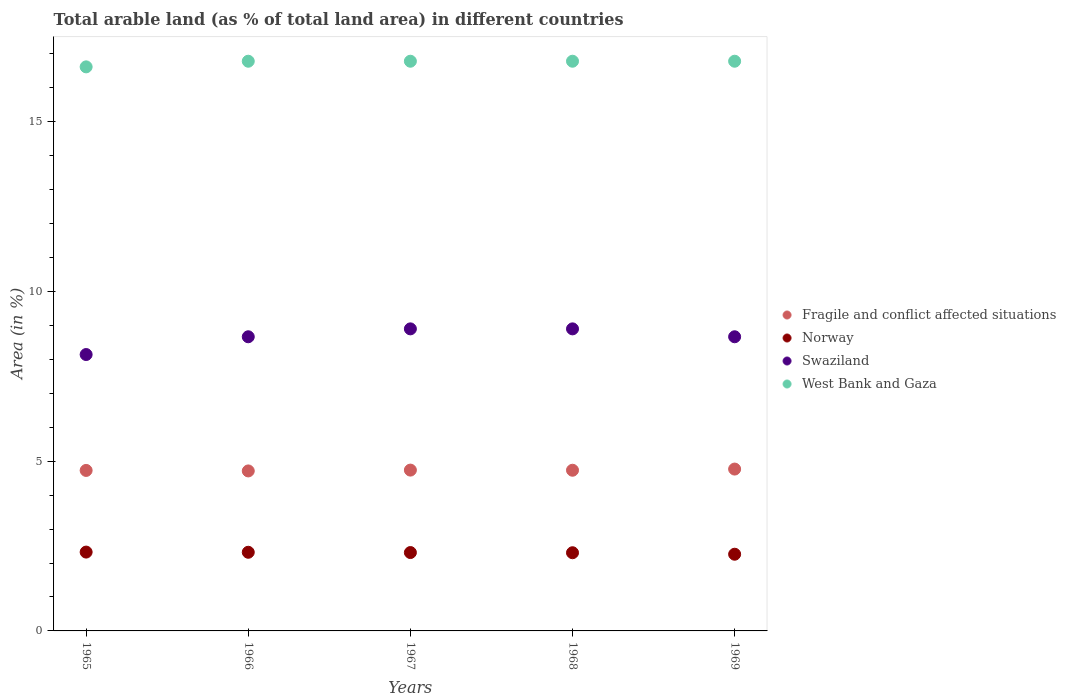What is the percentage of arable land in Fragile and conflict affected situations in 1968?
Your answer should be very brief. 4.73. Across all years, what is the maximum percentage of arable land in West Bank and Gaza?
Offer a very short reply. 16.78. Across all years, what is the minimum percentage of arable land in Swaziland?
Offer a very short reply. 8.14. In which year was the percentage of arable land in Swaziland maximum?
Your response must be concise. 1967. In which year was the percentage of arable land in Fragile and conflict affected situations minimum?
Ensure brevity in your answer.  1966. What is the total percentage of arable land in Norway in the graph?
Ensure brevity in your answer.  11.51. What is the difference between the percentage of arable land in Norway in 1966 and that in 1969?
Keep it short and to the point. 0.06. What is the difference between the percentage of arable land in Fragile and conflict affected situations in 1966 and the percentage of arable land in Swaziland in 1965?
Offer a very short reply. -3.43. What is the average percentage of arable land in Norway per year?
Keep it short and to the point. 2.3. In the year 1965, what is the difference between the percentage of arable land in Fragile and conflict affected situations and percentage of arable land in Swaziland?
Offer a terse response. -3.41. What is the ratio of the percentage of arable land in West Bank and Gaza in 1965 to that in 1967?
Make the answer very short. 0.99. Is the percentage of arable land in Norway in 1966 less than that in 1969?
Offer a very short reply. No. Is the difference between the percentage of arable land in Fragile and conflict affected situations in 1967 and 1968 greater than the difference between the percentage of arable land in Swaziland in 1967 and 1968?
Ensure brevity in your answer.  Yes. What is the difference between the highest and the lowest percentage of arable land in West Bank and Gaza?
Keep it short and to the point. 0.17. In how many years, is the percentage of arable land in Swaziland greater than the average percentage of arable land in Swaziland taken over all years?
Provide a short and direct response. 4. Is it the case that in every year, the sum of the percentage of arable land in Fragile and conflict affected situations and percentage of arable land in Norway  is greater than the percentage of arable land in West Bank and Gaza?
Keep it short and to the point. No. Does the percentage of arable land in Fragile and conflict affected situations monotonically increase over the years?
Keep it short and to the point. No. Is the percentage of arable land in Swaziland strictly greater than the percentage of arable land in West Bank and Gaza over the years?
Ensure brevity in your answer.  No. Is the percentage of arable land in Fragile and conflict affected situations strictly less than the percentage of arable land in Swaziland over the years?
Give a very brief answer. Yes. Are the values on the major ticks of Y-axis written in scientific E-notation?
Offer a terse response. No. Does the graph contain any zero values?
Offer a very short reply. No. Does the graph contain grids?
Ensure brevity in your answer.  No. How many legend labels are there?
Give a very brief answer. 4. How are the legend labels stacked?
Give a very brief answer. Vertical. What is the title of the graph?
Offer a very short reply. Total arable land (as % of total land area) in different countries. Does "Cuba" appear as one of the legend labels in the graph?
Provide a short and direct response. No. What is the label or title of the Y-axis?
Keep it short and to the point. Area (in %). What is the Area (in %) of Fragile and conflict affected situations in 1965?
Offer a very short reply. 4.73. What is the Area (in %) of Norway in 1965?
Your answer should be compact. 2.32. What is the Area (in %) of Swaziland in 1965?
Keep it short and to the point. 8.14. What is the Area (in %) in West Bank and Gaza in 1965?
Offer a very short reply. 16.61. What is the Area (in %) of Fragile and conflict affected situations in 1966?
Keep it short and to the point. 4.71. What is the Area (in %) of Norway in 1966?
Your response must be concise. 2.32. What is the Area (in %) in Swaziland in 1966?
Ensure brevity in your answer.  8.66. What is the Area (in %) in West Bank and Gaza in 1966?
Provide a succinct answer. 16.78. What is the Area (in %) in Fragile and conflict affected situations in 1967?
Your answer should be very brief. 4.74. What is the Area (in %) of Norway in 1967?
Ensure brevity in your answer.  2.31. What is the Area (in %) in Swaziland in 1967?
Offer a very short reply. 8.9. What is the Area (in %) in West Bank and Gaza in 1967?
Keep it short and to the point. 16.78. What is the Area (in %) of Fragile and conflict affected situations in 1968?
Make the answer very short. 4.73. What is the Area (in %) in Norway in 1968?
Offer a terse response. 2.3. What is the Area (in %) in Swaziland in 1968?
Provide a short and direct response. 8.9. What is the Area (in %) of West Bank and Gaza in 1968?
Your answer should be compact. 16.78. What is the Area (in %) of Fragile and conflict affected situations in 1969?
Give a very brief answer. 4.77. What is the Area (in %) in Norway in 1969?
Your answer should be very brief. 2.26. What is the Area (in %) in Swaziland in 1969?
Your response must be concise. 8.66. What is the Area (in %) of West Bank and Gaza in 1969?
Provide a short and direct response. 16.78. Across all years, what is the maximum Area (in %) in Fragile and conflict affected situations?
Give a very brief answer. 4.77. Across all years, what is the maximum Area (in %) of Norway?
Offer a terse response. 2.32. Across all years, what is the maximum Area (in %) in Swaziland?
Offer a terse response. 8.9. Across all years, what is the maximum Area (in %) of West Bank and Gaza?
Your answer should be very brief. 16.78. Across all years, what is the minimum Area (in %) of Fragile and conflict affected situations?
Provide a short and direct response. 4.71. Across all years, what is the minimum Area (in %) of Norway?
Provide a short and direct response. 2.26. Across all years, what is the minimum Area (in %) of Swaziland?
Keep it short and to the point. 8.14. Across all years, what is the minimum Area (in %) of West Bank and Gaza?
Your answer should be compact. 16.61. What is the total Area (in %) of Fragile and conflict affected situations in the graph?
Offer a terse response. 23.67. What is the total Area (in %) of Norway in the graph?
Ensure brevity in your answer.  11.51. What is the total Area (in %) of Swaziland in the graph?
Provide a short and direct response. 43.26. What is the total Area (in %) of West Bank and Gaza in the graph?
Make the answer very short. 83.72. What is the difference between the Area (in %) of Fragile and conflict affected situations in 1965 and that in 1966?
Your response must be concise. 0.01. What is the difference between the Area (in %) in Norway in 1965 and that in 1966?
Your answer should be compact. 0.01. What is the difference between the Area (in %) of Swaziland in 1965 and that in 1966?
Provide a succinct answer. -0.52. What is the difference between the Area (in %) of West Bank and Gaza in 1965 and that in 1966?
Provide a succinct answer. -0.17. What is the difference between the Area (in %) in Fragile and conflict affected situations in 1965 and that in 1967?
Provide a succinct answer. -0.01. What is the difference between the Area (in %) in Norway in 1965 and that in 1967?
Give a very brief answer. 0.01. What is the difference between the Area (in %) in Swaziland in 1965 and that in 1967?
Provide a succinct answer. -0.76. What is the difference between the Area (in %) of West Bank and Gaza in 1965 and that in 1967?
Ensure brevity in your answer.  -0.17. What is the difference between the Area (in %) in Fragile and conflict affected situations in 1965 and that in 1968?
Ensure brevity in your answer.  -0.01. What is the difference between the Area (in %) in Norway in 1965 and that in 1968?
Provide a succinct answer. 0.02. What is the difference between the Area (in %) of Swaziland in 1965 and that in 1968?
Provide a succinct answer. -0.76. What is the difference between the Area (in %) of West Bank and Gaza in 1965 and that in 1968?
Offer a terse response. -0.17. What is the difference between the Area (in %) of Fragile and conflict affected situations in 1965 and that in 1969?
Make the answer very short. -0.04. What is the difference between the Area (in %) of Norway in 1965 and that in 1969?
Offer a very short reply. 0.06. What is the difference between the Area (in %) of Swaziland in 1965 and that in 1969?
Provide a succinct answer. -0.52. What is the difference between the Area (in %) in West Bank and Gaza in 1965 and that in 1969?
Your response must be concise. -0.17. What is the difference between the Area (in %) in Fragile and conflict affected situations in 1966 and that in 1967?
Offer a very short reply. -0.02. What is the difference between the Area (in %) in Norway in 1966 and that in 1967?
Your answer should be very brief. 0.01. What is the difference between the Area (in %) in Swaziland in 1966 and that in 1967?
Your answer should be very brief. -0.23. What is the difference between the Area (in %) of West Bank and Gaza in 1966 and that in 1967?
Your answer should be very brief. 0. What is the difference between the Area (in %) of Fragile and conflict affected situations in 1966 and that in 1968?
Offer a terse response. -0.02. What is the difference between the Area (in %) in Norway in 1966 and that in 1968?
Offer a very short reply. 0.01. What is the difference between the Area (in %) in Swaziland in 1966 and that in 1968?
Ensure brevity in your answer.  -0.23. What is the difference between the Area (in %) in West Bank and Gaza in 1966 and that in 1968?
Your response must be concise. 0. What is the difference between the Area (in %) in Fragile and conflict affected situations in 1966 and that in 1969?
Your answer should be very brief. -0.05. What is the difference between the Area (in %) in Norway in 1966 and that in 1969?
Make the answer very short. 0.06. What is the difference between the Area (in %) of Swaziland in 1966 and that in 1969?
Provide a short and direct response. 0. What is the difference between the Area (in %) in Fragile and conflict affected situations in 1967 and that in 1968?
Ensure brevity in your answer.  0. What is the difference between the Area (in %) of Norway in 1967 and that in 1968?
Keep it short and to the point. 0.01. What is the difference between the Area (in %) of Swaziland in 1967 and that in 1968?
Your response must be concise. 0. What is the difference between the Area (in %) in West Bank and Gaza in 1967 and that in 1968?
Your response must be concise. 0. What is the difference between the Area (in %) of Fragile and conflict affected situations in 1967 and that in 1969?
Keep it short and to the point. -0.03. What is the difference between the Area (in %) in Norway in 1967 and that in 1969?
Offer a very short reply. 0.05. What is the difference between the Area (in %) of Swaziland in 1967 and that in 1969?
Give a very brief answer. 0.23. What is the difference between the Area (in %) in Fragile and conflict affected situations in 1968 and that in 1969?
Make the answer very short. -0.03. What is the difference between the Area (in %) in Norway in 1968 and that in 1969?
Your answer should be very brief. 0.04. What is the difference between the Area (in %) of Swaziland in 1968 and that in 1969?
Your response must be concise. 0.23. What is the difference between the Area (in %) in Fragile and conflict affected situations in 1965 and the Area (in %) in Norway in 1966?
Provide a short and direct response. 2.41. What is the difference between the Area (in %) of Fragile and conflict affected situations in 1965 and the Area (in %) of Swaziland in 1966?
Ensure brevity in your answer.  -3.94. What is the difference between the Area (in %) in Fragile and conflict affected situations in 1965 and the Area (in %) in West Bank and Gaza in 1966?
Provide a short and direct response. -12.05. What is the difference between the Area (in %) of Norway in 1965 and the Area (in %) of Swaziland in 1966?
Your response must be concise. -6.34. What is the difference between the Area (in %) of Norway in 1965 and the Area (in %) of West Bank and Gaza in 1966?
Give a very brief answer. -14.46. What is the difference between the Area (in %) in Swaziland in 1965 and the Area (in %) in West Bank and Gaza in 1966?
Make the answer very short. -8.64. What is the difference between the Area (in %) of Fragile and conflict affected situations in 1965 and the Area (in %) of Norway in 1967?
Your answer should be compact. 2.42. What is the difference between the Area (in %) in Fragile and conflict affected situations in 1965 and the Area (in %) in Swaziland in 1967?
Provide a short and direct response. -4.17. What is the difference between the Area (in %) of Fragile and conflict affected situations in 1965 and the Area (in %) of West Bank and Gaza in 1967?
Provide a succinct answer. -12.05. What is the difference between the Area (in %) of Norway in 1965 and the Area (in %) of Swaziland in 1967?
Provide a succinct answer. -6.57. What is the difference between the Area (in %) of Norway in 1965 and the Area (in %) of West Bank and Gaza in 1967?
Your response must be concise. -14.46. What is the difference between the Area (in %) of Swaziland in 1965 and the Area (in %) of West Bank and Gaza in 1967?
Ensure brevity in your answer.  -8.64. What is the difference between the Area (in %) in Fragile and conflict affected situations in 1965 and the Area (in %) in Norway in 1968?
Provide a short and direct response. 2.42. What is the difference between the Area (in %) of Fragile and conflict affected situations in 1965 and the Area (in %) of Swaziland in 1968?
Give a very brief answer. -4.17. What is the difference between the Area (in %) of Fragile and conflict affected situations in 1965 and the Area (in %) of West Bank and Gaza in 1968?
Your response must be concise. -12.05. What is the difference between the Area (in %) in Norway in 1965 and the Area (in %) in Swaziland in 1968?
Keep it short and to the point. -6.57. What is the difference between the Area (in %) in Norway in 1965 and the Area (in %) in West Bank and Gaza in 1968?
Your answer should be very brief. -14.46. What is the difference between the Area (in %) of Swaziland in 1965 and the Area (in %) of West Bank and Gaza in 1968?
Offer a very short reply. -8.64. What is the difference between the Area (in %) in Fragile and conflict affected situations in 1965 and the Area (in %) in Norway in 1969?
Your response must be concise. 2.47. What is the difference between the Area (in %) in Fragile and conflict affected situations in 1965 and the Area (in %) in Swaziland in 1969?
Offer a very short reply. -3.94. What is the difference between the Area (in %) in Fragile and conflict affected situations in 1965 and the Area (in %) in West Bank and Gaza in 1969?
Offer a very short reply. -12.05. What is the difference between the Area (in %) in Norway in 1965 and the Area (in %) in Swaziland in 1969?
Give a very brief answer. -6.34. What is the difference between the Area (in %) in Norway in 1965 and the Area (in %) in West Bank and Gaza in 1969?
Your answer should be very brief. -14.46. What is the difference between the Area (in %) of Swaziland in 1965 and the Area (in %) of West Bank and Gaza in 1969?
Make the answer very short. -8.64. What is the difference between the Area (in %) in Fragile and conflict affected situations in 1966 and the Area (in %) in Norway in 1967?
Your answer should be compact. 2.4. What is the difference between the Area (in %) in Fragile and conflict affected situations in 1966 and the Area (in %) in Swaziland in 1967?
Provide a succinct answer. -4.18. What is the difference between the Area (in %) of Fragile and conflict affected situations in 1966 and the Area (in %) of West Bank and Gaza in 1967?
Ensure brevity in your answer.  -12.07. What is the difference between the Area (in %) of Norway in 1966 and the Area (in %) of Swaziland in 1967?
Keep it short and to the point. -6.58. What is the difference between the Area (in %) in Norway in 1966 and the Area (in %) in West Bank and Gaza in 1967?
Offer a very short reply. -14.46. What is the difference between the Area (in %) in Swaziland in 1966 and the Area (in %) in West Bank and Gaza in 1967?
Your response must be concise. -8.11. What is the difference between the Area (in %) of Fragile and conflict affected situations in 1966 and the Area (in %) of Norway in 1968?
Ensure brevity in your answer.  2.41. What is the difference between the Area (in %) of Fragile and conflict affected situations in 1966 and the Area (in %) of Swaziland in 1968?
Provide a short and direct response. -4.18. What is the difference between the Area (in %) of Fragile and conflict affected situations in 1966 and the Area (in %) of West Bank and Gaza in 1968?
Offer a very short reply. -12.07. What is the difference between the Area (in %) in Norway in 1966 and the Area (in %) in Swaziland in 1968?
Offer a terse response. -6.58. What is the difference between the Area (in %) in Norway in 1966 and the Area (in %) in West Bank and Gaza in 1968?
Offer a very short reply. -14.46. What is the difference between the Area (in %) of Swaziland in 1966 and the Area (in %) of West Bank and Gaza in 1968?
Provide a short and direct response. -8.11. What is the difference between the Area (in %) in Fragile and conflict affected situations in 1966 and the Area (in %) in Norway in 1969?
Keep it short and to the point. 2.45. What is the difference between the Area (in %) of Fragile and conflict affected situations in 1966 and the Area (in %) of Swaziland in 1969?
Your answer should be compact. -3.95. What is the difference between the Area (in %) of Fragile and conflict affected situations in 1966 and the Area (in %) of West Bank and Gaza in 1969?
Provide a short and direct response. -12.07. What is the difference between the Area (in %) of Norway in 1966 and the Area (in %) of Swaziland in 1969?
Offer a very short reply. -6.35. What is the difference between the Area (in %) of Norway in 1966 and the Area (in %) of West Bank and Gaza in 1969?
Give a very brief answer. -14.46. What is the difference between the Area (in %) of Swaziland in 1966 and the Area (in %) of West Bank and Gaza in 1969?
Keep it short and to the point. -8.11. What is the difference between the Area (in %) in Fragile and conflict affected situations in 1967 and the Area (in %) in Norway in 1968?
Give a very brief answer. 2.43. What is the difference between the Area (in %) in Fragile and conflict affected situations in 1967 and the Area (in %) in Swaziland in 1968?
Provide a succinct answer. -4.16. What is the difference between the Area (in %) in Fragile and conflict affected situations in 1967 and the Area (in %) in West Bank and Gaza in 1968?
Keep it short and to the point. -12.04. What is the difference between the Area (in %) in Norway in 1967 and the Area (in %) in Swaziland in 1968?
Your answer should be very brief. -6.59. What is the difference between the Area (in %) in Norway in 1967 and the Area (in %) in West Bank and Gaza in 1968?
Give a very brief answer. -14.47. What is the difference between the Area (in %) of Swaziland in 1967 and the Area (in %) of West Bank and Gaza in 1968?
Ensure brevity in your answer.  -7.88. What is the difference between the Area (in %) of Fragile and conflict affected situations in 1967 and the Area (in %) of Norway in 1969?
Your answer should be very brief. 2.48. What is the difference between the Area (in %) of Fragile and conflict affected situations in 1967 and the Area (in %) of Swaziland in 1969?
Your response must be concise. -3.93. What is the difference between the Area (in %) in Fragile and conflict affected situations in 1967 and the Area (in %) in West Bank and Gaza in 1969?
Offer a very short reply. -12.04. What is the difference between the Area (in %) in Norway in 1967 and the Area (in %) in Swaziland in 1969?
Provide a succinct answer. -6.35. What is the difference between the Area (in %) in Norway in 1967 and the Area (in %) in West Bank and Gaza in 1969?
Provide a short and direct response. -14.47. What is the difference between the Area (in %) of Swaziland in 1967 and the Area (in %) of West Bank and Gaza in 1969?
Offer a terse response. -7.88. What is the difference between the Area (in %) in Fragile and conflict affected situations in 1968 and the Area (in %) in Norway in 1969?
Make the answer very short. 2.47. What is the difference between the Area (in %) in Fragile and conflict affected situations in 1968 and the Area (in %) in Swaziland in 1969?
Offer a very short reply. -3.93. What is the difference between the Area (in %) of Fragile and conflict affected situations in 1968 and the Area (in %) of West Bank and Gaza in 1969?
Offer a terse response. -12.05. What is the difference between the Area (in %) of Norway in 1968 and the Area (in %) of Swaziland in 1969?
Your answer should be very brief. -6.36. What is the difference between the Area (in %) in Norway in 1968 and the Area (in %) in West Bank and Gaza in 1969?
Your answer should be compact. -14.47. What is the difference between the Area (in %) of Swaziland in 1968 and the Area (in %) of West Bank and Gaza in 1969?
Give a very brief answer. -7.88. What is the average Area (in %) of Fragile and conflict affected situations per year?
Give a very brief answer. 4.73. What is the average Area (in %) of Norway per year?
Offer a very short reply. 2.3. What is the average Area (in %) in Swaziland per year?
Keep it short and to the point. 8.65. What is the average Area (in %) of West Bank and Gaza per year?
Make the answer very short. 16.74. In the year 1965, what is the difference between the Area (in %) in Fragile and conflict affected situations and Area (in %) in Norway?
Provide a short and direct response. 2.4. In the year 1965, what is the difference between the Area (in %) in Fragile and conflict affected situations and Area (in %) in Swaziland?
Give a very brief answer. -3.41. In the year 1965, what is the difference between the Area (in %) in Fragile and conflict affected situations and Area (in %) in West Bank and Gaza?
Make the answer very short. -11.88. In the year 1965, what is the difference between the Area (in %) of Norway and Area (in %) of Swaziland?
Keep it short and to the point. -5.82. In the year 1965, what is the difference between the Area (in %) of Norway and Area (in %) of West Bank and Gaza?
Provide a succinct answer. -14.29. In the year 1965, what is the difference between the Area (in %) of Swaziland and Area (in %) of West Bank and Gaza?
Your answer should be compact. -8.47. In the year 1966, what is the difference between the Area (in %) in Fragile and conflict affected situations and Area (in %) in Norway?
Give a very brief answer. 2.4. In the year 1966, what is the difference between the Area (in %) of Fragile and conflict affected situations and Area (in %) of Swaziland?
Your answer should be compact. -3.95. In the year 1966, what is the difference between the Area (in %) of Fragile and conflict affected situations and Area (in %) of West Bank and Gaza?
Your answer should be very brief. -12.07. In the year 1966, what is the difference between the Area (in %) in Norway and Area (in %) in Swaziland?
Offer a very short reply. -6.35. In the year 1966, what is the difference between the Area (in %) of Norway and Area (in %) of West Bank and Gaza?
Provide a succinct answer. -14.46. In the year 1966, what is the difference between the Area (in %) of Swaziland and Area (in %) of West Bank and Gaza?
Ensure brevity in your answer.  -8.11. In the year 1967, what is the difference between the Area (in %) in Fragile and conflict affected situations and Area (in %) in Norway?
Offer a terse response. 2.43. In the year 1967, what is the difference between the Area (in %) of Fragile and conflict affected situations and Area (in %) of Swaziland?
Make the answer very short. -4.16. In the year 1967, what is the difference between the Area (in %) of Fragile and conflict affected situations and Area (in %) of West Bank and Gaza?
Ensure brevity in your answer.  -12.04. In the year 1967, what is the difference between the Area (in %) of Norway and Area (in %) of Swaziland?
Your answer should be very brief. -6.59. In the year 1967, what is the difference between the Area (in %) in Norway and Area (in %) in West Bank and Gaza?
Your response must be concise. -14.47. In the year 1967, what is the difference between the Area (in %) in Swaziland and Area (in %) in West Bank and Gaza?
Provide a short and direct response. -7.88. In the year 1968, what is the difference between the Area (in %) in Fragile and conflict affected situations and Area (in %) in Norway?
Ensure brevity in your answer.  2.43. In the year 1968, what is the difference between the Area (in %) in Fragile and conflict affected situations and Area (in %) in Swaziland?
Offer a very short reply. -4.16. In the year 1968, what is the difference between the Area (in %) of Fragile and conflict affected situations and Area (in %) of West Bank and Gaza?
Make the answer very short. -12.05. In the year 1968, what is the difference between the Area (in %) in Norway and Area (in %) in Swaziland?
Your answer should be very brief. -6.59. In the year 1968, what is the difference between the Area (in %) of Norway and Area (in %) of West Bank and Gaza?
Offer a very short reply. -14.47. In the year 1968, what is the difference between the Area (in %) of Swaziland and Area (in %) of West Bank and Gaza?
Your response must be concise. -7.88. In the year 1969, what is the difference between the Area (in %) in Fragile and conflict affected situations and Area (in %) in Norway?
Your answer should be very brief. 2.51. In the year 1969, what is the difference between the Area (in %) of Fragile and conflict affected situations and Area (in %) of Swaziland?
Provide a succinct answer. -3.9. In the year 1969, what is the difference between the Area (in %) in Fragile and conflict affected situations and Area (in %) in West Bank and Gaza?
Keep it short and to the point. -12.01. In the year 1969, what is the difference between the Area (in %) of Norway and Area (in %) of Swaziland?
Offer a terse response. -6.4. In the year 1969, what is the difference between the Area (in %) of Norway and Area (in %) of West Bank and Gaza?
Keep it short and to the point. -14.52. In the year 1969, what is the difference between the Area (in %) in Swaziland and Area (in %) in West Bank and Gaza?
Ensure brevity in your answer.  -8.11. What is the ratio of the Area (in %) of Fragile and conflict affected situations in 1965 to that in 1966?
Ensure brevity in your answer.  1. What is the ratio of the Area (in %) of Swaziland in 1965 to that in 1966?
Offer a terse response. 0.94. What is the ratio of the Area (in %) in West Bank and Gaza in 1965 to that in 1966?
Give a very brief answer. 0.99. What is the ratio of the Area (in %) of Norway in 1965 to that in 1967?
Provide a succinct answer. 1.01. What is the ratio of the Area (in %) in Swaziland in 1965 to that in 1967?
Your answer should be compact. 0.92. What is the ratio of the Area (in %) in West Bank and Gaza in 1965 to that in 1967?
Offer a terse response. 0.99. What is the ratio of the Area (in %) in Fragile and conflict affected situations in 1965 to that in 1968?
Offer a terse response. 1. What is the ratio of the Area (in %) in Norway in 1965 to that in 1968?
Offer a very short reply. 1.01. What is the ratio of the Area (in %) of Swaziland in 1965 to that in 1968?
Provide a succinct answer. 0.92. What is the ratio of the Area (in %) in Fragile and conflict affected situations in 1965 to that in 1969?
Give a very brief answer. 0.99. What is the ratio of the Area (in %) in Norway in 1965 to that in 1969?
Provide a short and direct response. 1.03. What is the ratio of the Area (in %) in Swaziland in 1965 to that in 1969?
Make the answer very short. 0.94. What is the ratio of the Area (in %) in West Bank and Gaza in 1965 to that in 1969?
Provide a succinct answer. 0.99. What is the ratio of the Area (in %) in Norway in 1966 to that in 1967?
Keep it short and to the point. 1. What is the ratio of the Area (in %) of Swaziland in 1966 to that in 1967?
Offer a very short reply. 0.97. What is the ratio of the Area (in %) in Fragile and conflict affected situations in 1966 to that in 1968?
Provide a short and direct response. 1. What is the ratio of the Area (in %) of Norway in 1966 to that in 1968?
Provide a short and direct response. 1.01. What is the ratio of the Area (in %) in Swaziland in 1966 to that in 1968?
Make the answer very short. 0.97. What is the ratio of the Area (in %) of West Bank and Gaza in 1966 to that in 1968?
Your response must be concise. 1. What is the ratio of the Area (in %) in Fragile and conflict affected situations in 1966 to that in 1969?
Make the answer very short. 0.99. What is the ratio of the Area (in %) in Norway in 1966 to that in 1969?
Give a very brief answer. 1.03. What is the ratio of the Area (in %) in West Bank and Gaza in 1966 to that in 1969?
Your answer should be compact. 1. What is the ratio of the Area (in %) of Fragile and conflict affected situations in 1967 to that in 1968?
Your answer should be very brief. 1. What is the ratio of the Area (in %) in West Bank and Gaza in 1967 to that in 1968?
Offer a terse response. 1. What is the ratio of the Area (in %) in Fragile and conflict affected situations in 1967 to that in 1969?
Make the answer very short. 0.99. What is the ratio of the Area (in %) in Norway in 1967 to that in 1969?
Give a very brief answer. 1.02. What is the ratio of the Area (in %) in Swaziland in 1967 to that in 1969?
Offer a terse response. 1.03. What is the ratio of the Area (in %) of West Bank and Gaza in 1967 to that in 1969?
Your answer should be very brief. 1. What is the ratio of the Area (in %) of Fragile and conflict affected situations in 1968 to that in 1969?
Keep it short and to the point. 0.99. What is the ratio of the Area (in %) of Norway in 1968 to that in 1969?
Keep it short and to the point. 1.02. What is the ratio of the Area (in %) of Swaziland in 1968 to that in 1969?
Provide a succinct answer. 1.03. What is the ratio of the Area (in %) in West Bank and Gaza in 1968 to that in 1969?
Offer a very short reply. 1. What is the difference between the highest and the second highest Area (in %) of Fragile and conflict affected situations?
Ensure brevity in your answer.  0.03. What is the difference between the highest and the second highest Area (in %) in Norway?
Your answer should be compact. 0.01. What is the difference between the highest and the second highest Area (in %) of Swaziland?
Offer a terse response. 0. What is the difference between the highest and the lowest Area (in %) of Fragile and conflict affected situations?
Provide a short and direct response. 0.05. What is the difference between the highest and the lowest Area (in %) in Norway?
Provide a short and direct response. 0.06. What is the difference between the highest and the lowest Area (in %) of Swaziland?
Provide a succinct answer. 0.76. What is the difference between the highest and the lowest Area (in %) in West Bank and Gaza?
Make the answer very short. 0.17. 